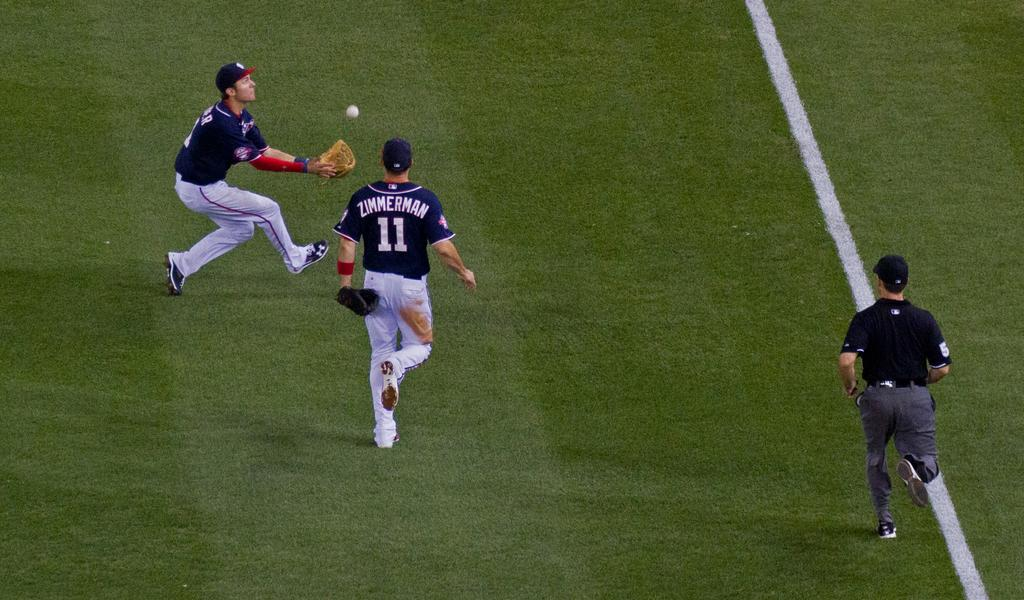<image>
Give a short and clear explanation of the subsequent image. Two baseball players are running to catch the ball and one of their uniforms says Zimmerman on the back. 